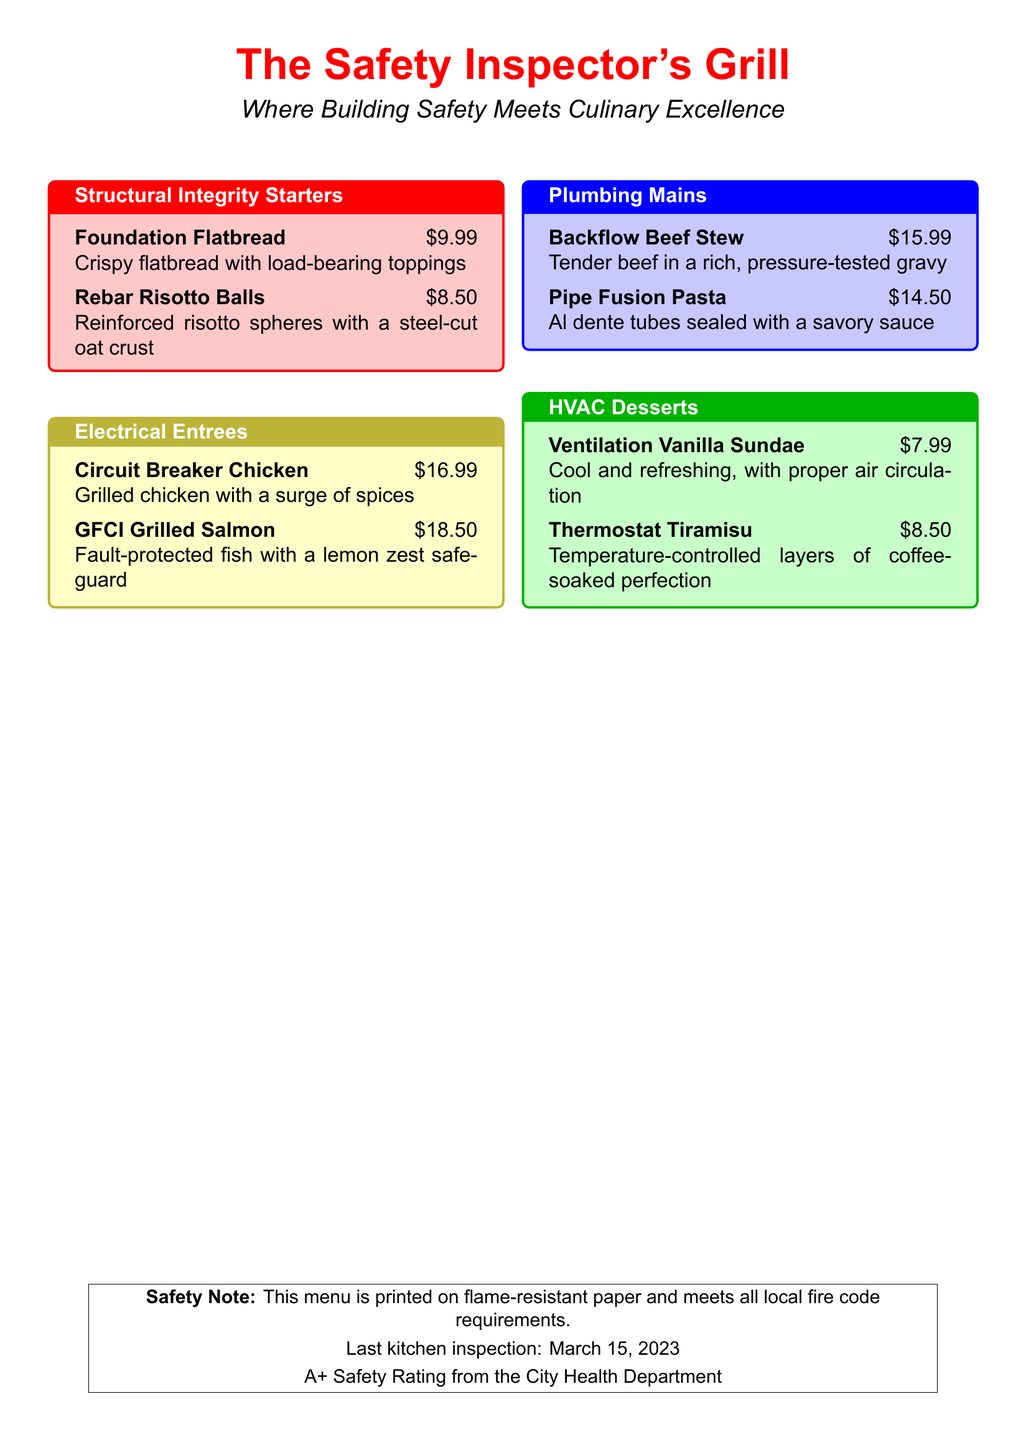What is the name of the restaurant? The name of the restaurant is displayed prominently at the top of the menu.
Answer: The Safety Inspector's Grill What is the price of Rebar Risotto Balls? The price for Rebar Risotto Balls is mentioned next to the item in the Structural Integrity Starters section.
Answer: $8.50 What type of dessert is offered in the HVAC Desserts section? The type of desserts in this section is indicated by the titles of the items listed.
Answer: Sundae, Tiramisu How much does Circuit Breaker Chicken cost? The cost of Circuit Breaker Chicken is stated in the Electrical Entrees section.
Answer: $16.99 On what date was the last kitchen inspection? The date of the last kitchen inspection is provided in the safety note at the bottom of the menu.
Answer: March 15, 2023 What section does Pipe Fusion Pasta belong to? The section is designated by the title and color-coded box within the menu.
Answer: Plumbing Mains What type of paper is the menu printed on? The type of paper used for the menu is indicated in the safety note at the bottom.
Answer: Flame-resistant paper What is the A+ rating from the City Health Department related to? The A+ rating pertains to safety standards mentioned in the safety note.
Answer: Safety Rating How many starters are listed in the Structural Integrity Starters section? The count of starters is based on the items listed in that section of the menu.
Answer: Two 